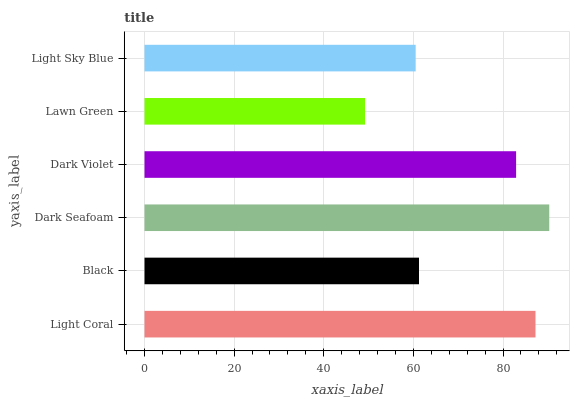Is Lawn Green the minimum?
Answer yes or no. Yes. Is Dark Seafoam the maximum?
Answer yes or no. Yes. Is Black the minimum?
Answer yes or no. No. Is Black the maximum?
Answer yes or no. No. Is Light Coral greater than Black?
Answer yes or no. Yes. Is Black less than Light Coral?
Answer yes or no. Yes. Is Black greater than Light Coral?
Answer yes or no. No. Is Light Coral less than Black?
Answer yes or no. No. Is Dark Violet the high median?
Answer yes or no. Yes. Is Black the low median?
Answer yes or no. Yes. Is Dark Seafoam the high median?
Answer yes or no. No. Is Dark Violet the low median?
Answer yes or no. No. 